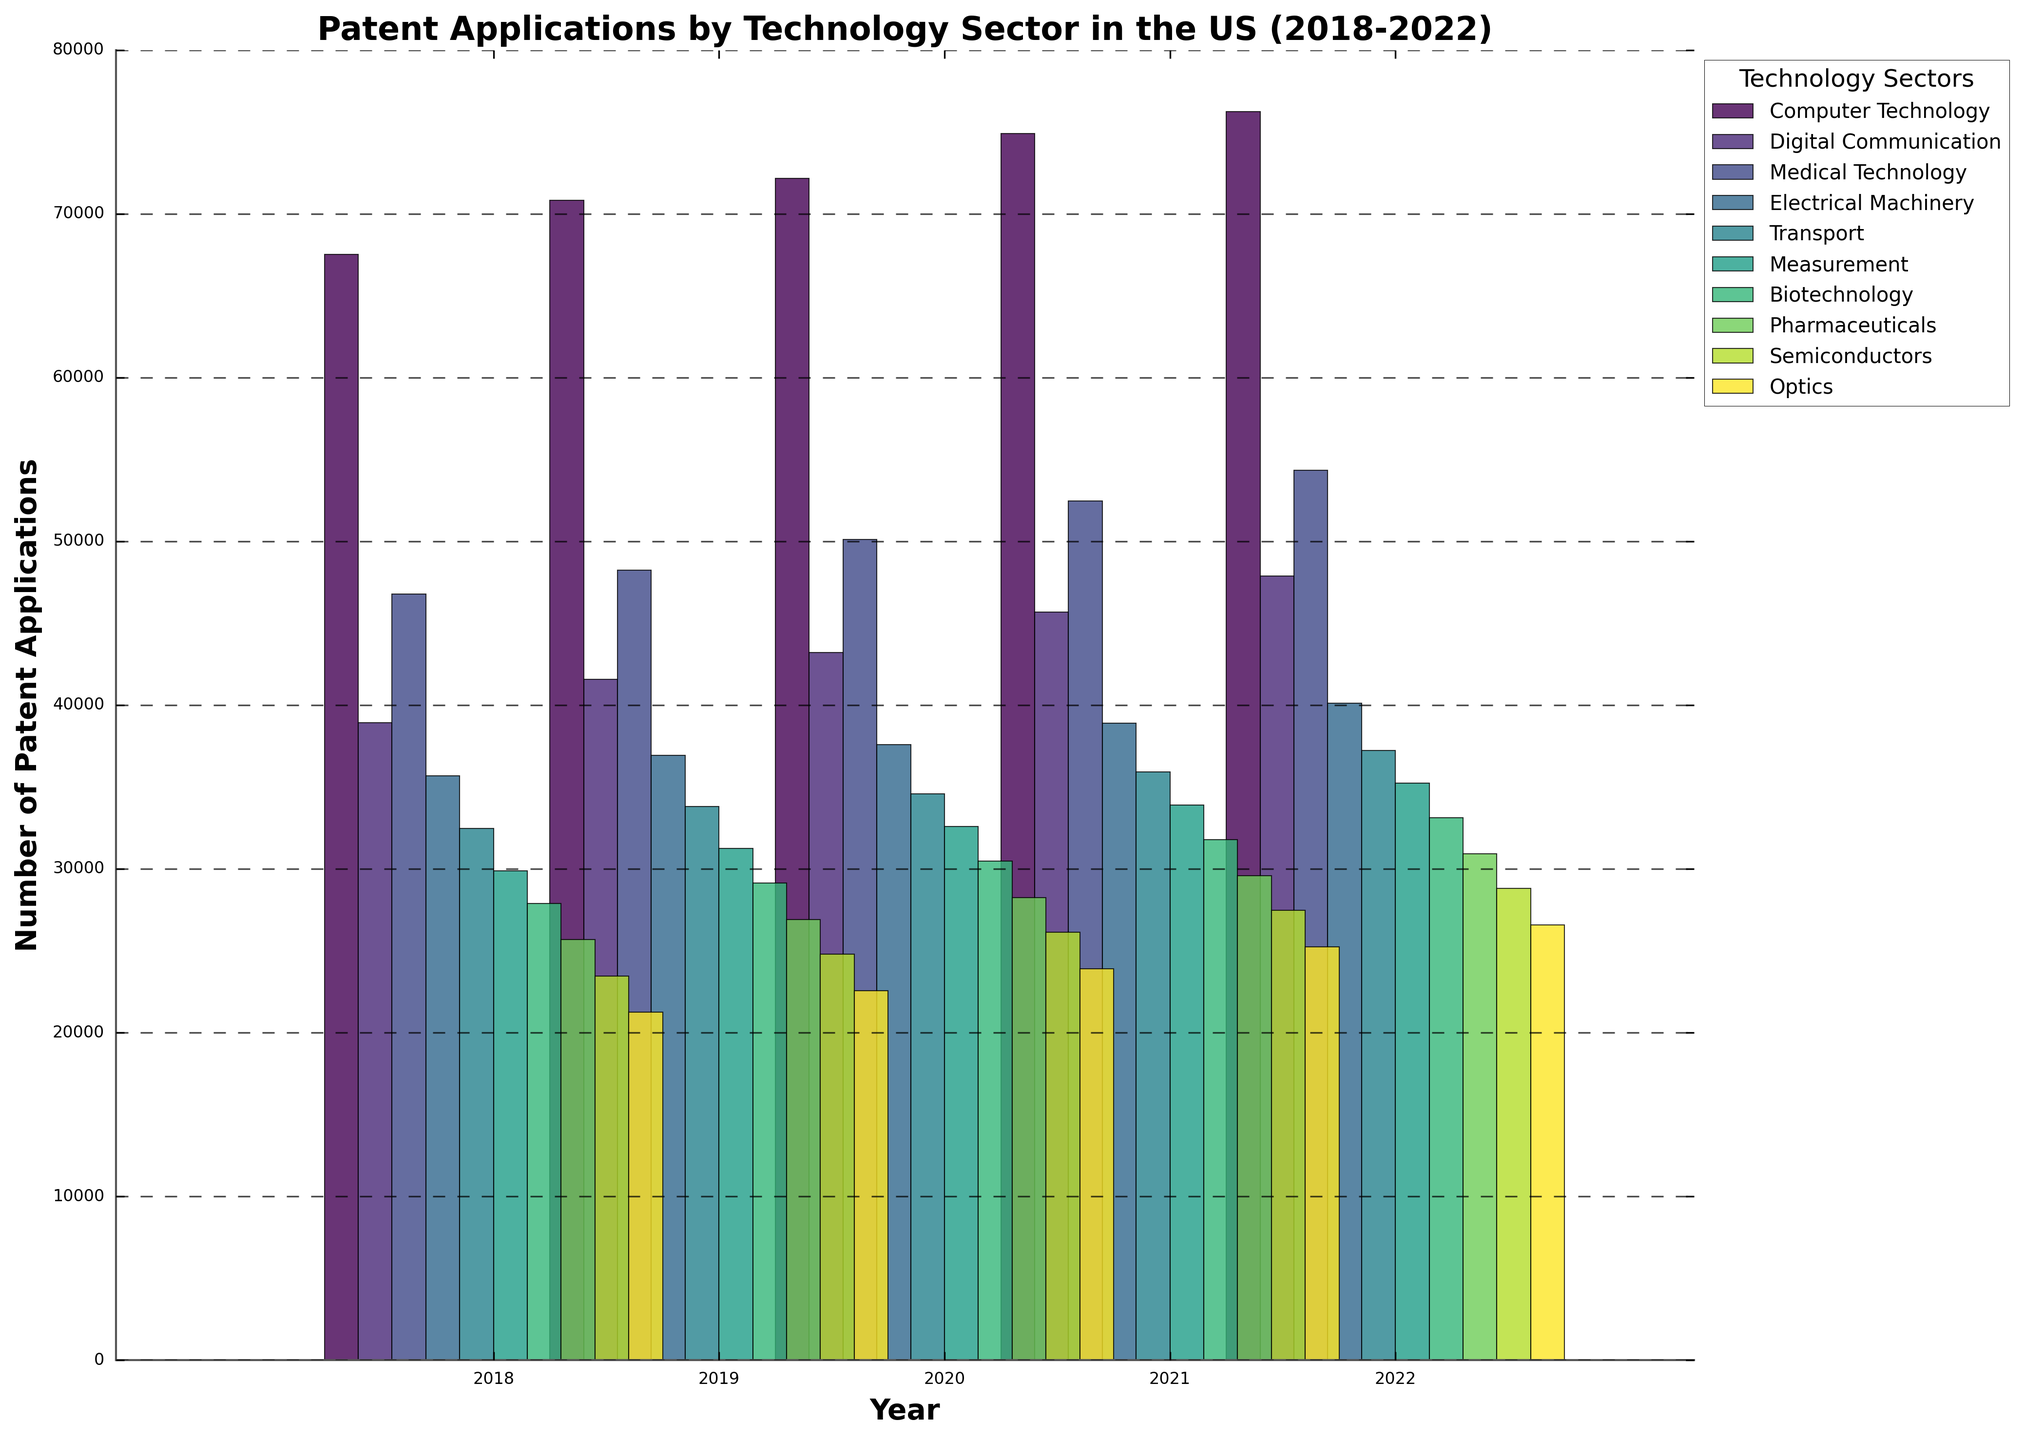What technology sector had the highest number of patent applications in 2022? Look at the height of the bars for each sector in 2022 and identify the tallest bar. The tallest bar corresponds to the sector with the highest number of applications.
Answer: Computer Technology What is the average number of patent applications for Medical Technology from 2018 to 2022? Sum the numbers for Medical Technology from each year (46789 + 48234 + 50123 + 52456 + 54321) and divide by the number of years (5). The calculation is (46789 + 48234 + 50123 + 52456 + 54321) / 5.
Answer: 50385 How did the number of patent applications in Digital Communication change from 2018 to 2019? Subtract the number of applications in 2018 from those in 2019 (41567 - 38912). This gives the change.
Answer: Increased by 2655 Which technology sector showed the least growth in patent applications between 2018 and 2022? Calculate the difference in the number of patent applications between 2018 and 2022 for each sector and identify the smallest difference.
Answer: Optics What's the total number of patent applications in the Transport sector for all the years combined? Sum the numbers for Transport from each year (32456 + 33789 + 34567 + 35901 + 37234). The calculation is 32456 + 33789 + 34567 + 35901 + 37234.
Answer: 173947 In which year did Semiconductors see the highest number of patent applications, and what was the number? Look at the height of the bars for Semiconductors across all years and identify the tallest bar, then read the number above that bar.
Answer: 2022, 28789 How did the number of patent applications in Biotechnology compare to Pharmaceuticals in 2020? Compare the height of the bars for Biotechnology and Pharmaceuticals in 2020. Biotechnology: 30456, Pharmaceuticals: 28234.
Answer: Biotechnology had more applications Calculate the overall increase in patent applications for Electrical Machinery from 2018 to 2022. Subtract the number of applications in 2018 from those in 2022 (40123 - 35678). This gives the overall increase.
Answer: Increased by 4445 Which sector had a higher average number of patent applications from 2018 to 2022, Biotechnology or Optics? Calculate the average number of applications for both sectors and compare them. Biotechnology: (27890 + 29123 + 30456 + 31789 + 33123) / 5 = 30476.2, Optics: (21234 + 22567 + 23901 + 25234 + 26567) / 5 = 23801.
Answer: Biotechnology What is the color of the bars representing the Transport sector in the plot? Identify the color of the bars used for the Transport sector based on the plot's legend.
Answer: Specific color (as seen in the legend) 